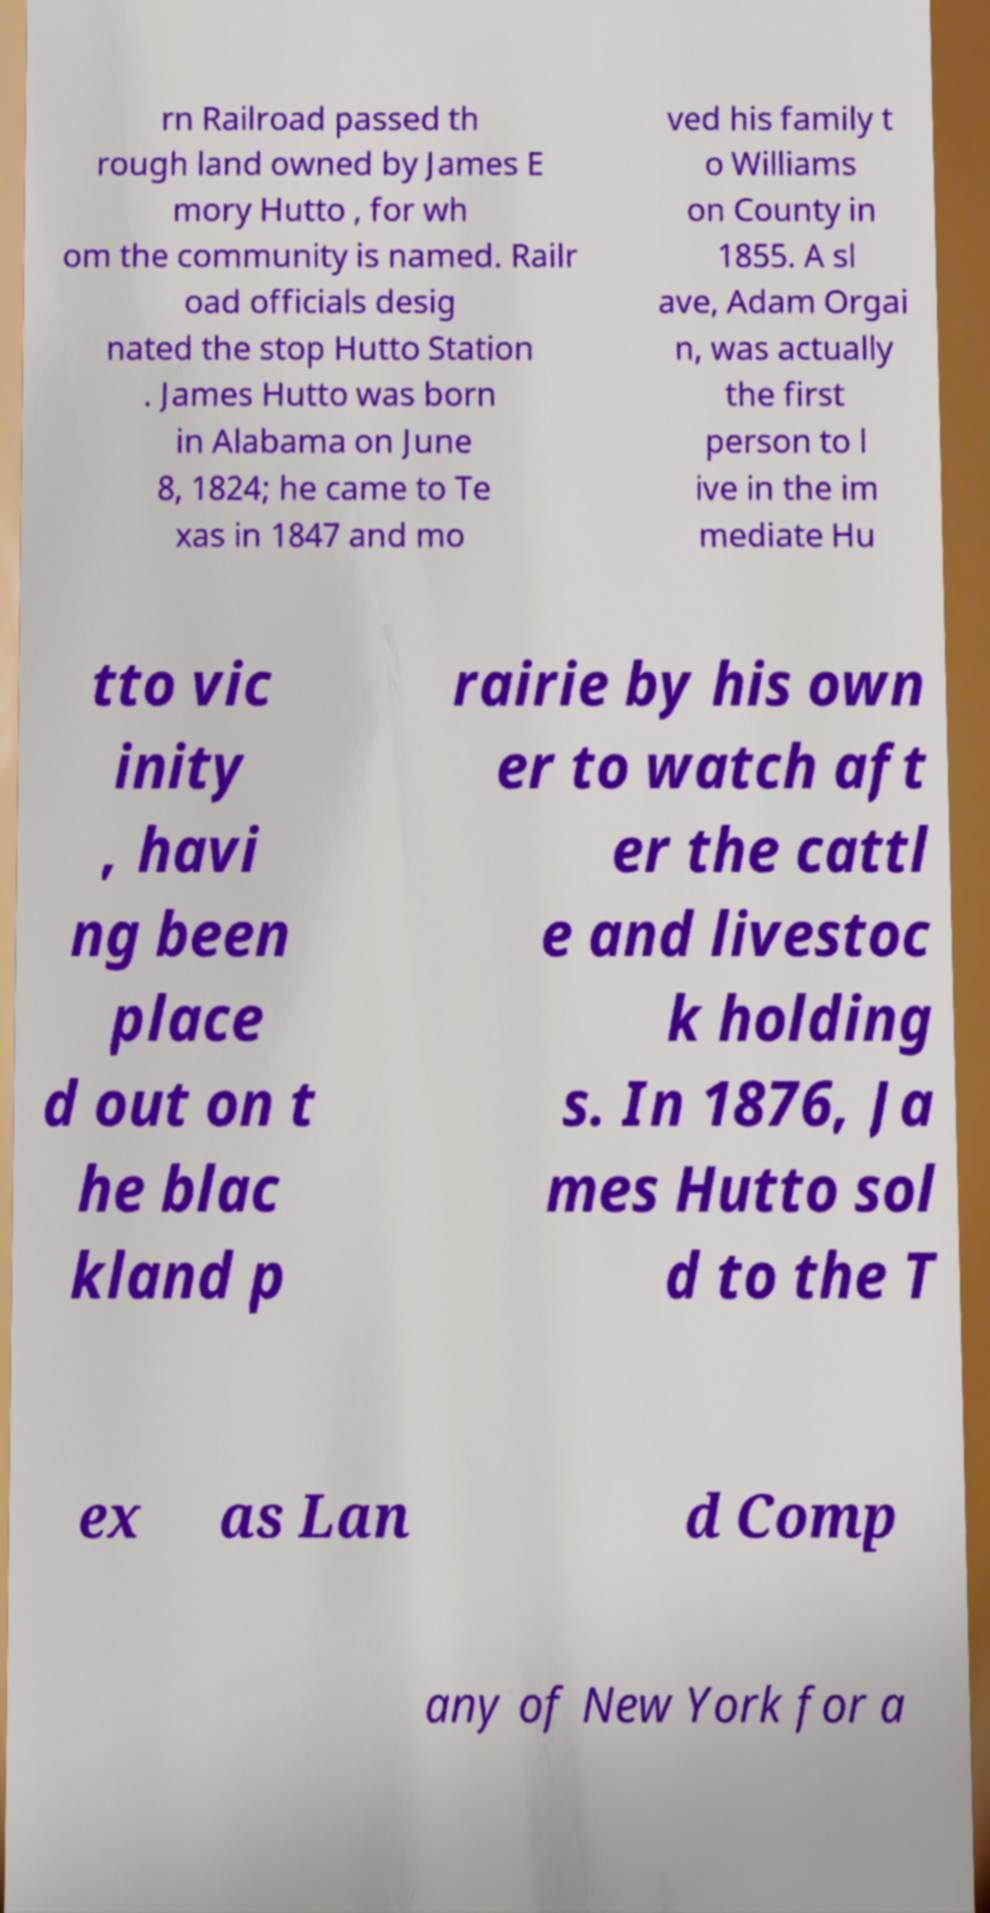I need the written content from this picture converted into text. Can you do that? rn Railroad passed th rough land owned by James E mory Hutto , for wh om the community is named. Railr oad officials desig nated the stop Hutto Station . James Hutto was born in Alabama on June 8, 1824; he came to Te xas in 1847 and mo ved his family t o Williams on County in 1855. A sl ave, Adam Orgai n, was actually the first person to l ive in the im mediate Hu tto vic inity , havi ng been place d out on t he blac kland p rairie by his own er to watch aft er the cattl e and livestoc k holding s. In 1876, Ja mes Hutto sol d to the T ex as Lan d Comp any of New York for a 